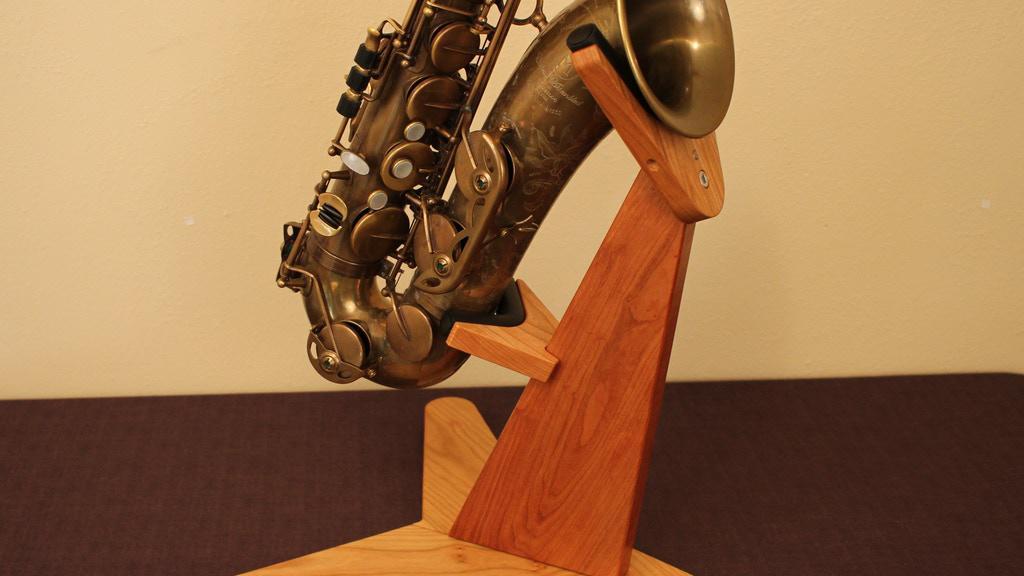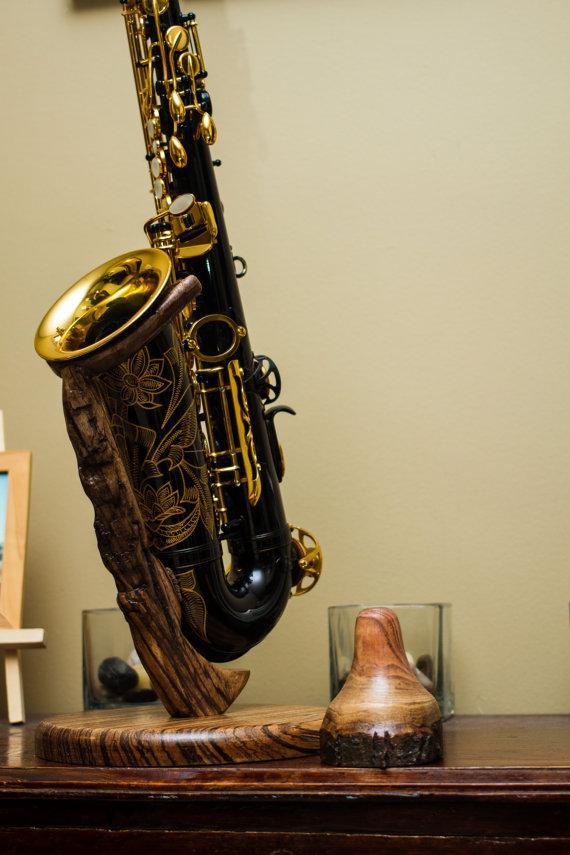The first image is the image on the left, the second image is the image on the right. Considering the images on both sides, is "All the instruments are on a stand." valid? Answer yes or no. Yes. 